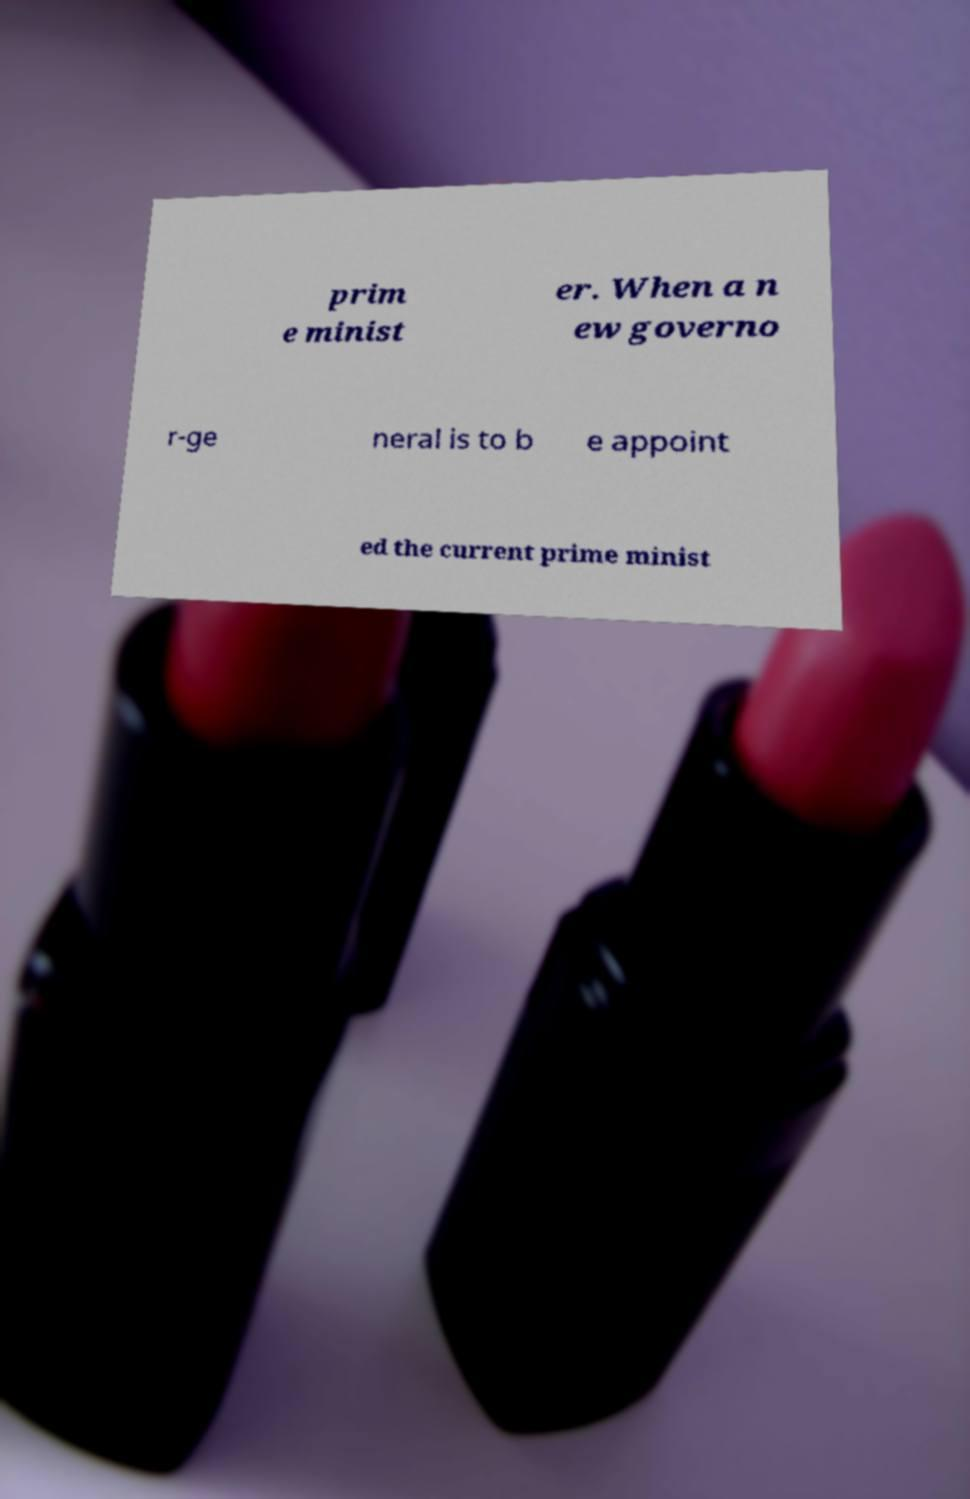Could you extract and type out the text from this image? prim e minist er. When a n ew governo r-ge neral is to b e appoint ed the current prime minist 